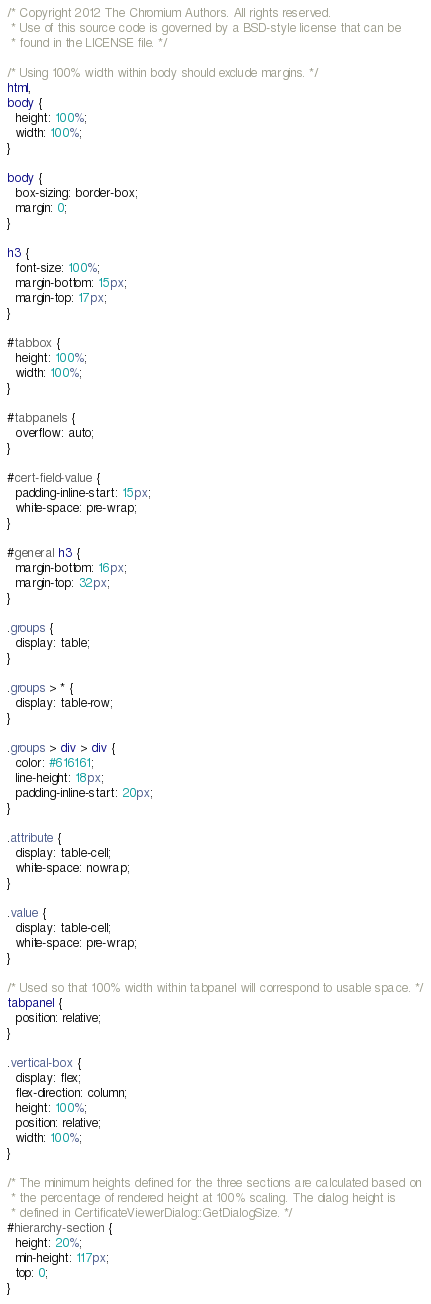<code> <loc_0><loc_0><loc_500><loc_500><_CSS_>/* Copyright 2012 The Chromium Authors. All rights reserved.
 * Use of this source code is governed by a BSD-style license that can be
 * found in the LICENSE file. */

/* Using 100% width within body should exclude margins. */
html,
body {
  height: 100%;
  width: 100%;
}

body {
  box-sizing: border-box;
  margin: 0;
}

h3 {
  font-size: 100%;
  margin-bottom: 15px;
  margin-top: 17px;
}

#tabbox {
  height: 100%;
  width: 100%;
}

#tabpanels {
  overflow: auto;
}

#cert-field-value {
  padding-inline-start: 15px;
  white-space: pre-wrap;
}

#general h3 {
  margin-bottom: 16px;
  margin-top: 32px;
}

.groups {
  display: table;
}

.groups > * {
  display: table-row;
}

.groups > div > div {
  color: #616161;
  line-height: 18px;
  padding-inline-start: 20px;
}

.attribute {
  display: table-cell;
  white-space: nowrap;
}

.value {
  display: table-cell;
  white-space: pre-wrap;
}

/* Used so that 100% width within tabpanel will correspond to usable space. */
tabpanel {
  position: relative;
}

.vertical-box {
  display: flex;
  flex-direction: column;
  height: 100%;
  position: relative;
  width: 100%;
}

/* The minimum heights defined for the three sections are calculated based on
 * the percentage of rendered height at 100% scaling. The dialog height is
 * defined in CertificateViewerDialog::GetDialogSize. */
#hierarchy-section {
  height: 20%;
  min-height: 117px;
  top: 0;
}
</code> 